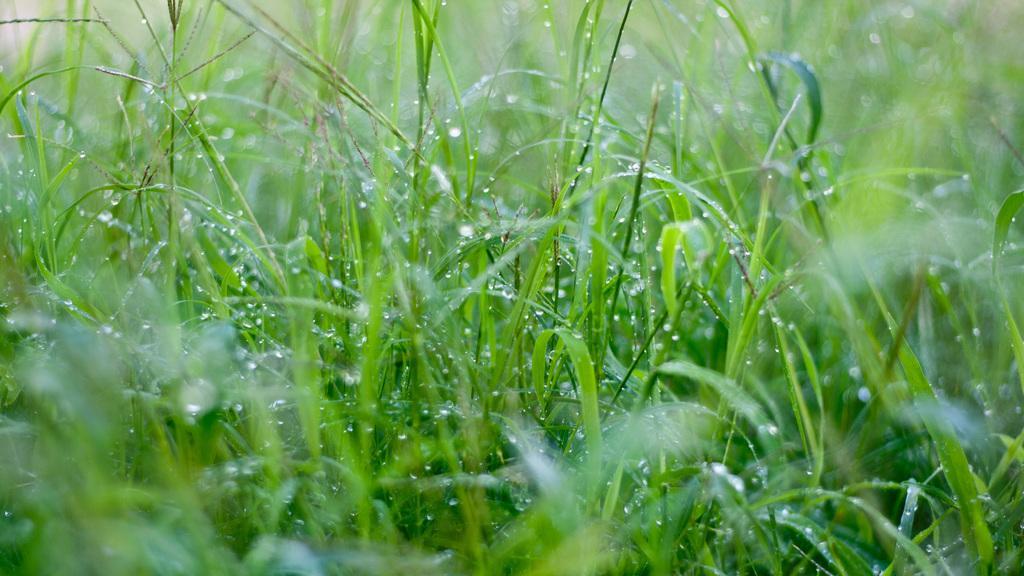Please provide a concise description of this image. There is grass. On the grass there are water droplets. 